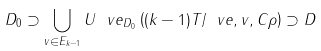Convert formula to latex. <formula><loc_0><loc_0><loc_500><loc_500>D _ { 0 } \supset \bigcup _ { v \in E _ { k - 1 } } U ^ { \ } v e _ { D _ { 0 } } \left ( ( k - 1 ) T / \ v e , v , C \rho \right ) \supset D</formula> 